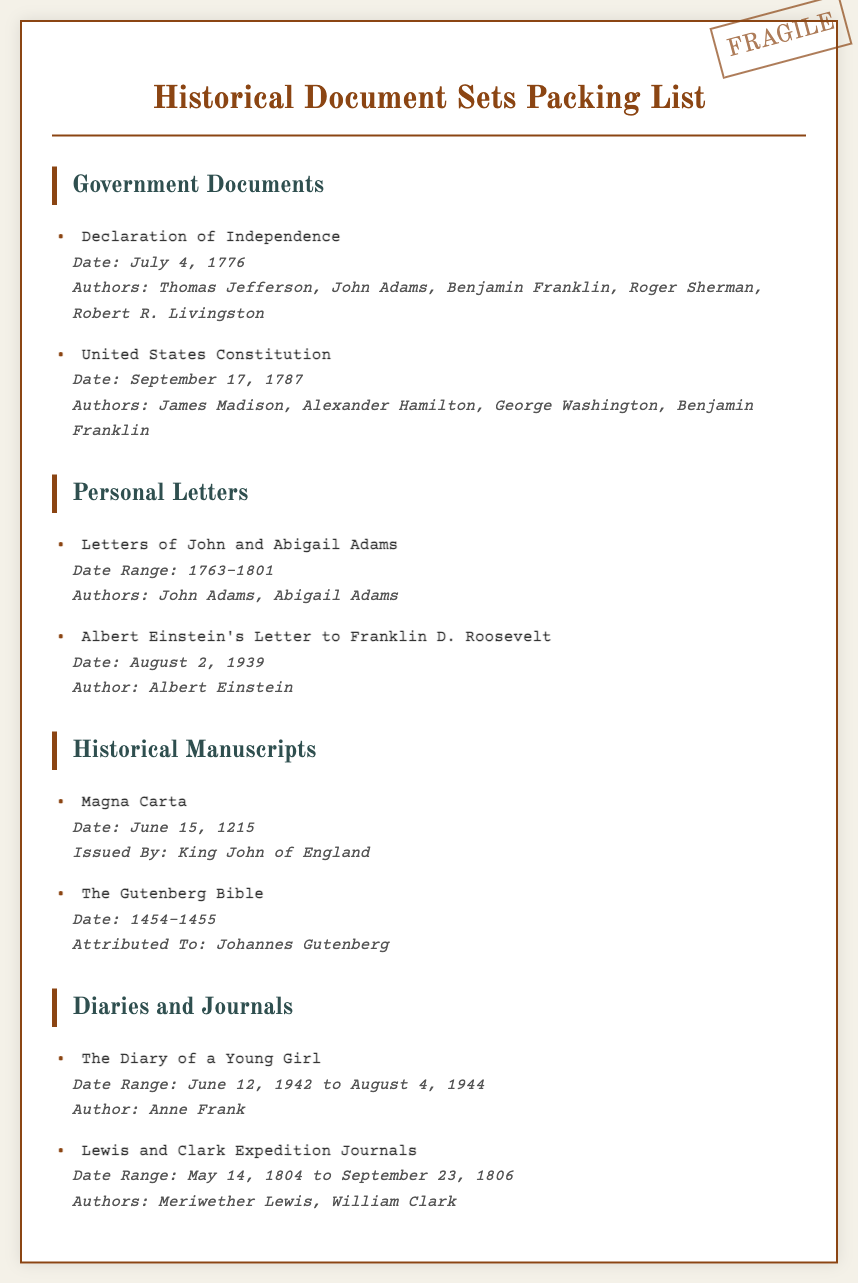What is the date of the Declaration of Independence? The date of the Declaration of Independence is specified directly in the document.
Answer: July 4, 1776 Who authored the United States Constitution? The authors of the United States Constitution are listed in the document.
Answer: James Madison, Alexander Hamilton, George Washington, Benjamin Franklin What is the date range for the Letters of John and Abigail Adams? The document provides the date range for these letters.
Answer: 1763-1801 Who issued the Magna Carta? The document names the issuer of the Magna Carta.
Answer: King John of England What is the date of Albert Einstein's letter to Franklin D. Roosevelt? The specific date of the letter is mentioned in the document.
Answer: August 2, 1939 How long is the date range of Anne Frank's diary? The date range for Anne Frank's diary is provided in the document.
Answer: June 12, 1942 to August 4, 1944 Which historical manuscript is attributed to Johannes Gutenberg? The document explicitly attributes the manuscript to Johannes Gutenberg.
Answer: The Gutenberg Bible What are the names of the authors of the Lewis and Clark Expedition Journals? The authors of the journals are listed in the document.
Answer: Meriwether Lewis, William Clark 